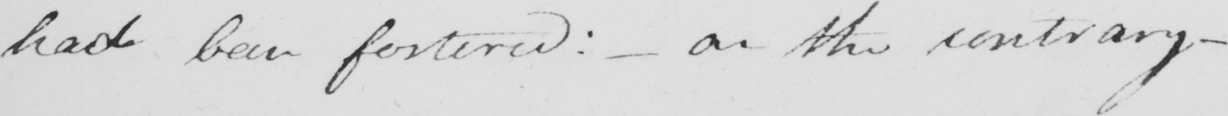What is written in this line of handwriting? had been fostered :   _  or the contrary  _ 